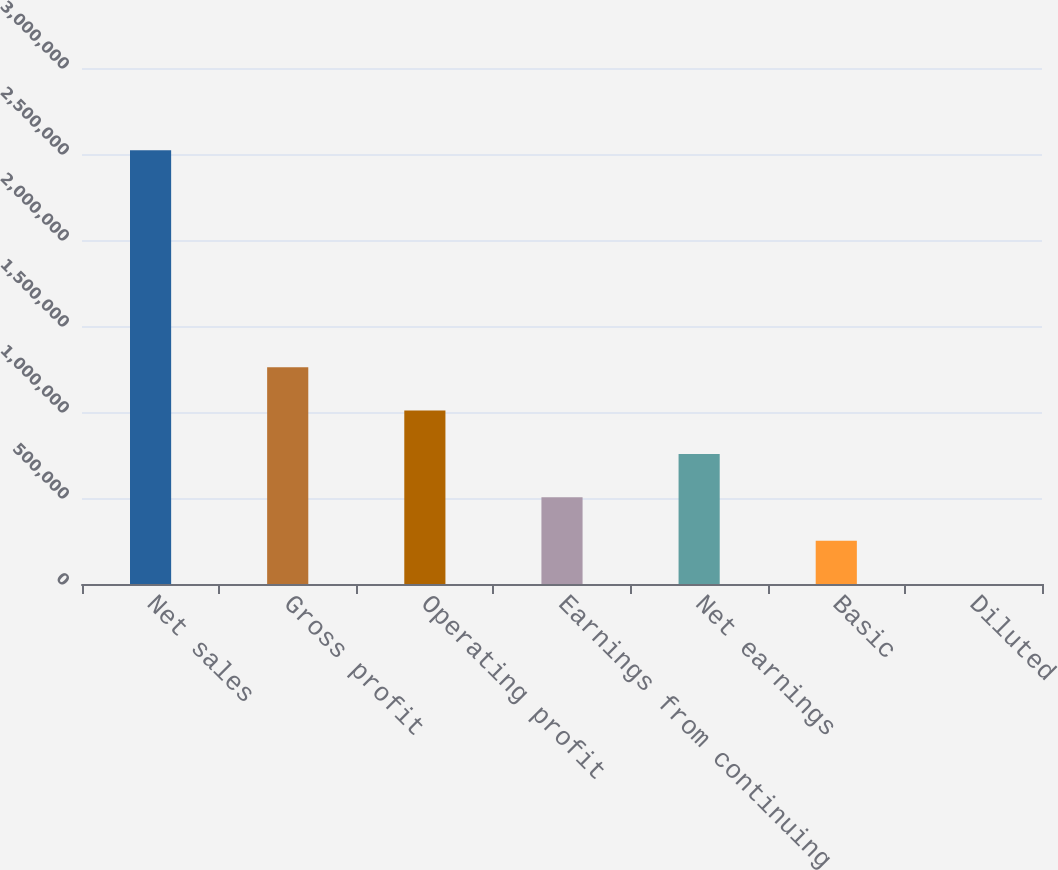<chart> <loc_0><loc_0><loc_500><loc_500><bar_chart><fcel>Net sales<fcel>Gross profit<fcel>Operating profit<fcel>Earnings from continuing<fcel>Net earnings<fcel>Basic<fcel>Diluted<nl><fcel>2.5217e+06<fcel>1.26085e+06<fcel>1.00868e+06<fcel>504341<fcel>756512<fcel>252171<fcel>0.77<nl></chart> 